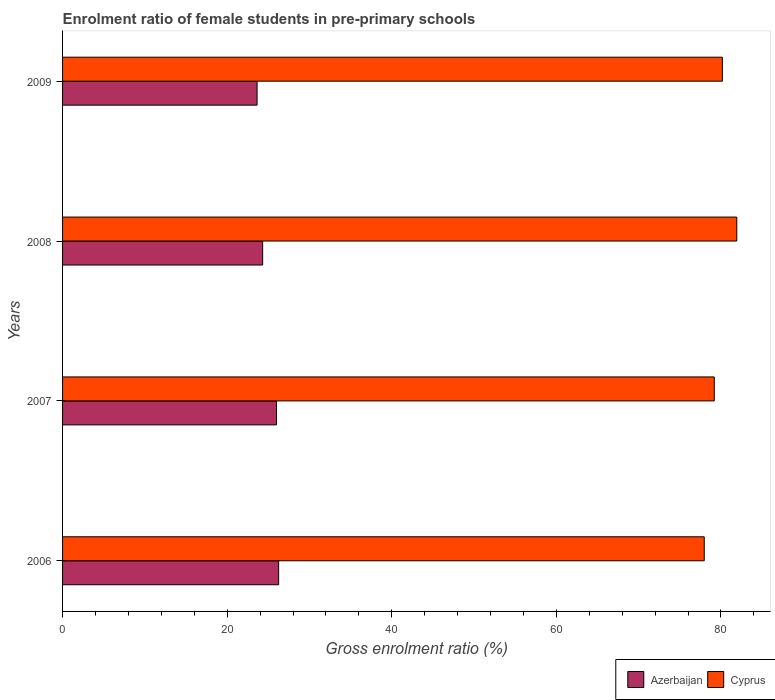Are the number of bars per tick equal to the number of legend labels?
Provide a short and direct response. Yes. What is the label of the 1st group of bars from the top?
Give a very brief answer. 2009. In how many cases, is the number of bars for a given year not equal to the number of legend labels?
Ensure brevity in your answer.  0. What is the enrolment ratio of female students in pre-primary schools in Cyprus in 2008?
Your answer should be compact. 81.92. Across all years, what is the maximum enrolment ratio of female students in pre-primary schools in Azerbaijan?
Keep it short and to the point. 26.25. Across all years, what is the minimum enrolment ratio of female students in pre-primary schools in Azerbaijan?
Make the answer very short. 23.63. In which year was the enrolment ratio of female students in pre-primary schools in Cyprus maximum?
Offer a very short reply. 2008. What is the total enrolment ratio of female students in pre-primary schools in Cyprus in the graph?
Offer a very short reply. 319.25. What is the difference between the enrolment ratio of female students in pre-primary schools in Cyprus in 2006 and that in 2008?
Your answer should be compact. -3.95. What is the difference between the enrolment ratio of female students in pre-primary schools in Cyprus in 2008 and the enrolment ratio of female students in pre-primary schools in Azerbaijan in 2007?
Offer a very short reply. 55.93. What is the average enrolment ratio of female students in pre-primary schools in Azerbaijan per year?
Give a very brief answer. 25.05. In the year 2007, what is the difference between the enrolment ratio of female students in pre-primary schools in Cyprus and enrolment ratio of female students in pre-primary schools in Azerbaijan?
Provide a succinct answer. 53.19. In how many years, is the enrolment ratio of female students in pre-primary schools in Cyprus greater than 36 %?
Make the answer very short. 4. What is the ratio of the enrolment ratio of female students in pre-primary schools in Azerbaijan in 2006 to that in 2009?
Your answer should be very brief. 1.11. Is the difference between the enrolment ratio of female students in pre-primary schools in Cyprus in 2007 and 2009 greater than the difference between the enrolment ratio of female students in pre-primary schools in Azerbaijan in 2007 and 2009?
Your response must be concise. No. What is the difference between the highest and the second highest enrolment ratio of female students in pre-primary schools in Azerbaijan?
Keep it short and to the point. 0.26. What is the difference between the highest and the lowest enrolment ratio of female students in pre-primary schools in Azerbaijan?
Offer a terse response. 2.62. In how many years, is the enrolment ratio of female students in pre-primary schools in Azerbaijan greater than the average enrolment ratio of female students in pre-primary schools in Azerbaijan taken over all years?
Keep it short and to the point. 2. Is the sum of the enrolment ratio of female students in pre-primary schools in Cyprus in 2008 and 2009 greater than the maximum enrolment ratio of female students in pre-primary schools in Azerbaijan across all years?
Your response must be concise. Yes. What does the 1st bar from the top in 2007 represents?
Make the answer very short. Cyprus. What does the 2nd bar from the bottom in 2007 represents?
Ensure brevity in your answer.  Cyprus. How many bars are there?
Offer a terse response. 8. Are all the bars in the graph horizontal?
Your response must be concise. Yes. What is the difference between two consecutive major ticks on the X-axis?
Ensure brevity in your answer.  20. Does the graph contain any zero values?
Offer a terse response. No. Does the graph contain grids?
Make the answer very short. No. What is the title of the graph?
Ensure brevity in your answer.  Enrolment ratio of female students in pre-primary schools. What is the label or title of the Y-axis?
Provide a short and direct response. Years. What is the Gross enrolment ratio (%) in Azerbaijan in 2006?
Provide a short and direct response. 26.25. What is the Gross enrolment ratio (%) of Cyprus in 2006?
Make the answer very short. 77.97. What is the Gross enrolment ratio (%) in Azerbaijan in 2007?
Your answer should be very brief. 26. What is the Gross enrolment ratio (%) in Cyprus in 2007?
Ensure brevity in your answer.  79.19. What is the Gross enrolment ratio (%) in Azerbaijan in 2008?
Make the answer very short. 24.31. What is the Gross enrolment ratio (%) of Cyprus in 2008?
Your answer should be compact. 81.92. What is the Gross enrolment ratio (%) of Azerbaijan in 2009?
Keep it short and to the point. 23.63. What is the Gross enrolment ratio (%) in Cyprus in 2009?
Your response must be concise. 80.17. Across all years, what is the maximum Gross enrolment ratio (%) of Azerbaijan?
Provide a succinct answer. 26.25. Across all years, what is the maximum Gross enrolment ratio (%) of Cyprus?
Keep it short and to the point. 81.92. Across all years, what is the minimum Gross enrolment ratio (%) in Azerbaijan?
Your response must be concise. 23.63. Across all years, what is the minimum Gross enrolment ratio (%) of Cyprus?
Provide a succinct answer. 77.97. What is the total Gross enrolment ratio (%) of Azerbaijan in the graph?
Your answer should be very brief. 100.2. What is the total Gross enrolment ratio (%) in Cyprus in the graph?
Give a very brief answer. 319.25. What is the difference between the Gross enrolment ratio (%) in Azerbaijan in 2006 and that in 2007?
Give a very brief answer. 0.26. What is the difference between the Gross enrolment ratio (%) in Cyprus in 2006 and that in 2007?
Provide a succinct answer. -1.22. What is the difference between the Gross enrolment ratio (%) of Azerbaijan in 2006 and that in 2008?
Give a very brief answer. 1.94. What is the difference between the Gross enrolment ratio (%) of Cyprus in 2006 and that in 2008?
Ensure brevity in your answer.  -3.95. What is the difference between the Gross enrolment ratio (%) of Azerbaijan in 2006 and that in 2009?
Your answer should be very brief. 2.62. What is the difference between the Gross enrolment ratio (%) in Cyprus in 2006 and that in 2009?
Provide a succinct answer. -2.2. What is the difference between the Gross enrolment ratio (%) of Azerbaijan in 2007 and that in 2008?
Provide a short and direct response. 1.68. What is the difference between the Gross enrolment ratio (%) of Cyprus in 2007 and that in 2008?
Ensure brevity in your answer.  -2.73. What is the difference between the Gross enrolment ratio (%) of Azerbaijan in 2007 and that in 2009?
Give a very brief answer. 2.36. What is the difference between the Gross enrolment ratio (%) in Cyprus in 2007 and that in 2009?
Offer a terse response. -0.98. What is the difference between the Gross enrolment ratio (%) in Azerbaijan in 2008 and that in 2009?
Provide a short and direct response. 0.68. What is the difference between the Gross enrolment ratio (%) in Cyprus in 2008 and that in 2009?
Your answer should be compact. 1.75. What is the difference between the Gross enrolment ratio (%) of Azerbaijan in 2006 and the Gross enrolment ratio (%) of Cyprus in 2007?
Provide a succinct answer. -52.93. What is the difference between the Gross enrolment ratio (%) of Azerbaijan in 2006 and the Gross enrolment ratio (%) of Cyprus in 2008?
Provide a succinct answer. -55.67. What is the difference between the Gross enrolment ratio (%) of Azerbaijan in 2006 and the Gross enrolment ratio (%) of Cyprus in 2009?
Offer a terse response. -53.92. What is the difference between the Gross enrolment ratio (%) in Azerbaijan in 2007 and the Gross enrolment ratio (%) in Cyprus in 2008?
Your response must be concise. -55.93. What is the difference between the Gross enrolment ratio (%) in Azerbaijan in 2007 and the Gross enrolment ratio (%) in Cyprus in 2009?
Give a very brief answer. -54.18. What is the difference between the Gross enrolment ratio (%) in Azerbaijan in 2008 and the Gross enrolment ratio (%) in Cyprus in 2009?
Provide a short and direct response. -55.86. What is the average Gross enrolment ratio (%) in Azerbaijan per year?
Offer a terse response. 25.05. What is the average Gross enrolment ratio (%) of Cyprus per year?
Keep it short and to the point. 79.81. In the year 2006, what is the difference between the Gross enrolment ratio (%) of Azerbaijan and Gross enrolment ratio (%) of Cyprus?
Make the answer very short. -51.71. In the year 2007, what is the difference between the Gross enrolment ratio (%) in Azerbaijan and Gross enrolment ratio (%) in Cyprus?
Give a very brief answer. -53.19. In the year 2008, what is the difference between the Gross enrolment ratio (%) in Azerbaijan and Gross enrolment ratio (%) in Cyprus?
Your answer should be very brief. -57.61. In the year 2009, what is the difference between the Gross enrolment ratio (%) in Azerbaijan and Gross enrolment ratio (%) in Cyprus?
Offer a very short reply. -56.54. What is the ratio of the Gross enrolment ratio (%) of Cyprus in 2006 to that in 2007?
Provide a succinct answer. 0.98. What is the ratio of the Gross enrolment ratio (%) in Azerbaijan in 2006 to that in 2008?
Your answer should be compact. 1.08. What is the ratio of the Gross enrolment ratio (%) in Cyprus in 2006 to that in 2008?
Provide a short and direct response. 0.95. What is the ratio of the Gross enrolment ratio (%) in Azerbaijan in 2006 to that in 2009?
Your answer should be compact. 1.11. What is the ratio of the Gross enrolment ratio (%) in Cyprus in 2006 to that in 2009?
Ensure brevity in your answer.  0.97. What is the ratio of the Gross enrolment ratio (%) of Azerbaijan in 2007 to that in 2008?
Provide a succinct answer. 1.07. What is the ratio of the Gross enrolment ratio (%) in Cyprus in 2007 to that in 2008?
Make the answer very short. 0.97. What is the ratio of the Gross enrolment ratio (%) in Azerbaijan in 2007 to that in 2009?
Your answer should be very brief. 1.1. What is the ratio of the Gross enrolment ratio (%) of Cyprus in 2007 to that in 2009?
Your answer should be very brief. 0.99. What is the ratio of the Gross enrolment ratio (%) in Azerbaijan in 2008 to that in 2009?
Provide a succinct answer. 1.03. What is the ratio of the Gross enrolment ratio (%) of Cyprus in 2008 to that in 2009?
Give a very brief answer. 1.02. What is the difference between the highest and the second highest Gross enrolment ratio (%) of Azerbaijan?
Ensure brevity in your answer.  0.26. What is the difference between the highest and the second highest Gross enrolment ratio (%) of Cyprus?
Provide a succinct answer. 1.75. What is the difference between the highest and the lowest Gross enrolment ratio (%) of Azerbaijan?
Give a very brief answer. 2.62. What is the difference between the highest and the lowest Gross enrolment ratio (%) of Cyprus?
Your answer should be very brief. 3.95. 